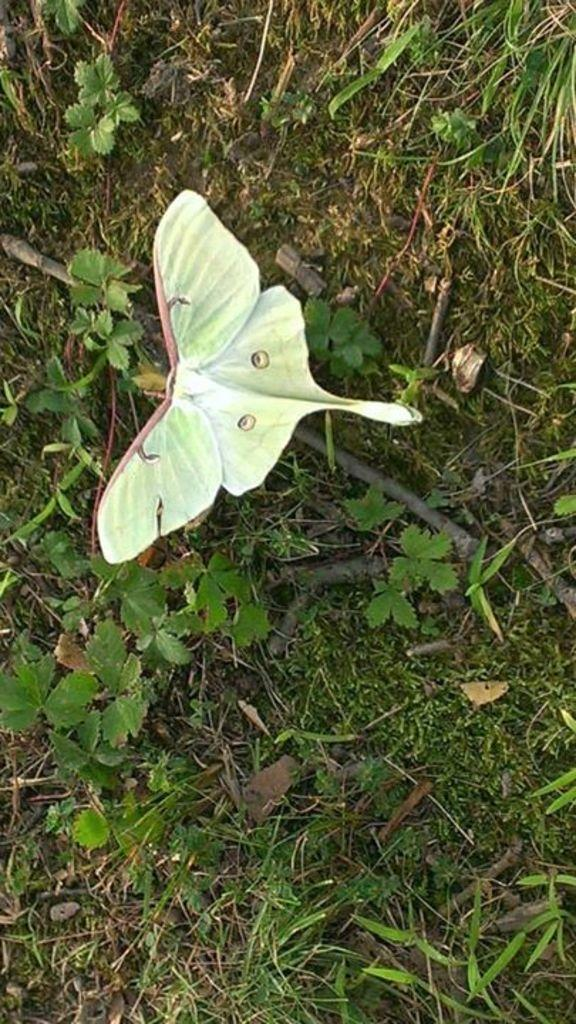What type of animal can be seen in the image? There is a butterfly in the image. What color are the plants in the image? The plants in the image are green. What type of cat can be seen playing with a glass on the edge of the image? There is no cat or glass present in the image; it features a butterfly and green color plants. 